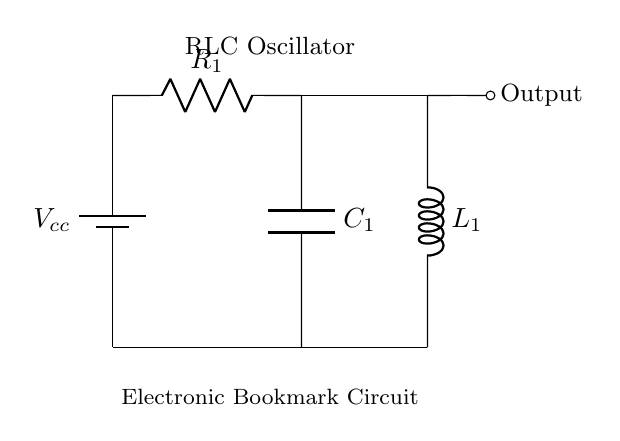What components are present in this circuit? The circuit consists of a resistor, an inductor, and a capacitor. These components are arranged to form an RLC oscillator.
Answer: Resistor, Inductor, Capacitor What is the function of the capacitor in this circuit? The capacitor stores and releases energy, contributing to the oscillatory behavior of the RLC circuit. It helps to set the frequency of oscillation as it charges and discharges.
Answer: Energy storage What is the role of the inductor in this circuit? The inductor creates a magnetic field when current passes through it, which allows it to store energy. It works with the capacitor to create oscillations in the circuit.
Answer: Energy storage What type of circuit is this? The circuit is a series RLC oscillator, which uses a resistor, a capacitor, and an inductor to generate oscillations.
Answer: Series RLC oscillator How many nodes are there in the circuit? There are four nodes in the circuit, which include the connections between the battery, resistor, inductor, and capacitor.
Answer: Four nodes What is the significance of the output in this circuit? The output of the circuit is important for indicating or tracking the reading time, as it represents the oscillations created by the RLC components.
Answer: Tracking reading time What is the voltage source label in the circuit? The voltage source is labeled as Vcc, which is the supply voltage for the RLC circuit.
Answer: Vcc 